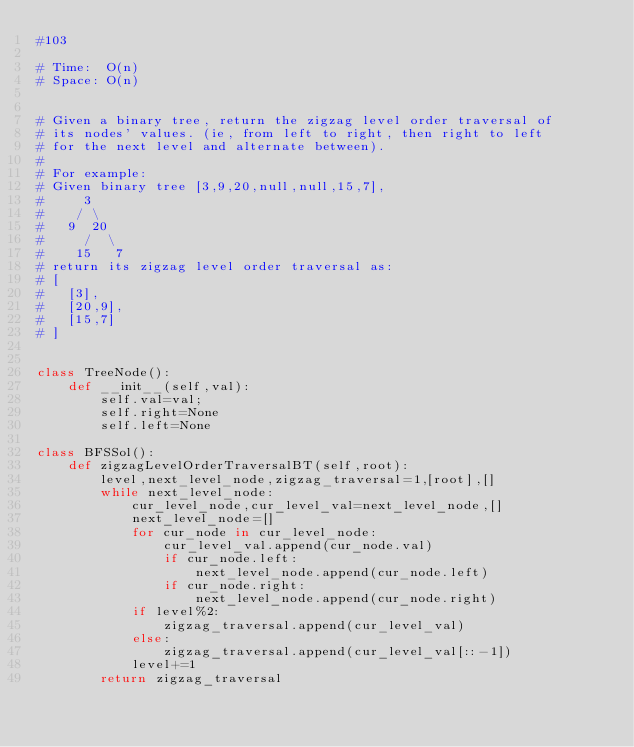Convert code to text. <code><loc_0><loc_0><loc_500><loc_500><_Python_>#103

# Time:  O(n)
# Space: O(n)


# Given a binary tree, return the zigzag level order traversal of 
# its nodes' values. (ie, from left to right, then right to left 
# for the next level and alternate between).
#
# For example:
# Given binary tree [3,9,20,null,null,15,7],
#     3
#    / \
#   9  20
#     /  \
#    15   7
# return its zigzag level order traversal as:
# [
#   [3],
#   [20,9],
#   [15,7]
# ]


class TreeNode():
    def __init__(self,val):
        self.val=val;
        self.right=None
        self.left=None

class BFSSol():
    def zigzagLevelOrderTraversalBT(self,root):
        level,next_level_node,zigzag_traversal=1,[root],[]
        while next_level_node:
            cur_level_node,cur_level_val=next_level_node,[]
            next_level_node=[]
            for cur_node in cur_level_node:
                cur_level_val.append(cur_node.val)
                if cur_node.left:
                    next_level_node.append(cur_node.left)
                if cur_node.right:
                    next_level_node.append(cur_node.right)
            if level%2:
                zigzag_traversal.append(cur_level_val)
            else:
                zigzag_traversal.append(cur_level_val[::-1])
            level+=1
        return zigzag_traversal
</code> 